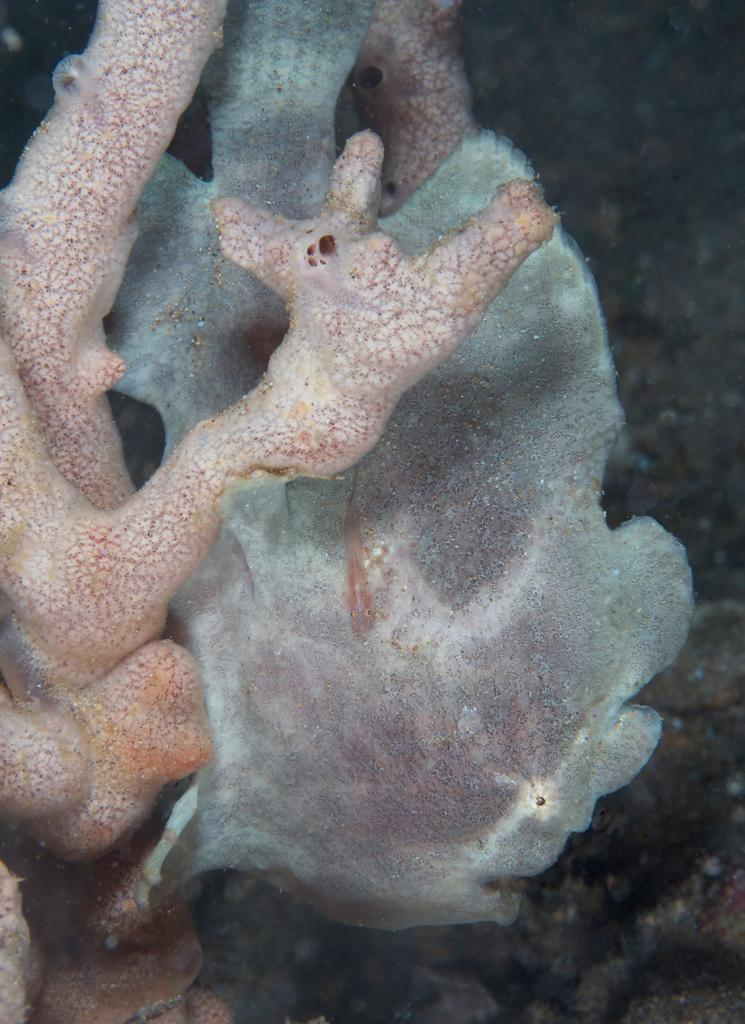What type of environment is shown in the image? The image depicts an underwater environment. What type of tin can be seen in the image? There is no tin present in the image, as it depicts an underwater environment. How many dogs are visible in the image? There are no dogs present in the image, as it depicts an underwater environment. 